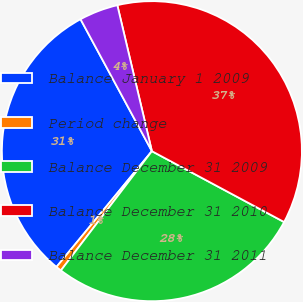Convert chart to OTSL. <chart><loc_0><loc_0><loc_500><loc_500><pie_chart><fcel>Balance January 1 2009<fcel>Period change<fcel>Balance December 31 2009<fcel>Balance December 31 2010<fcel>Balance December 31 2011<nl><fcel>31.14%<fcel>0.6%<fcel>27.54%<fcel>36.53%<fcel>4.19%<nl></chart> 